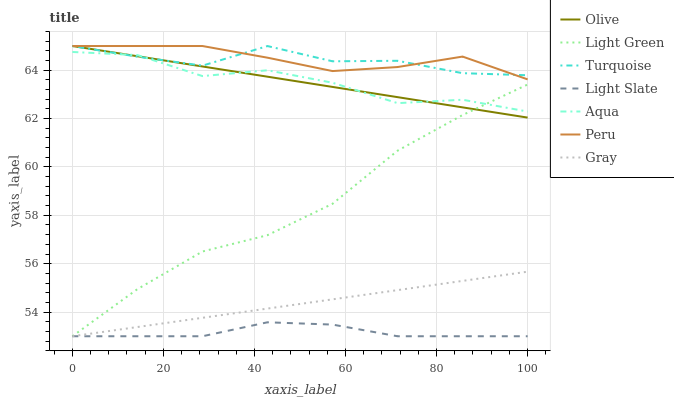Does Light Slate have the minimum area under the curve?
Answer yes or no. Yes. Does Peru have the maximum area under the curve?
Answer yes or no. Yes. Does Turquoise have the minimum area under the curve?
Answer yes or no. No. Does Turquoise have the maximum area under the curve?
Answer yes or no. No. Is Gray the smoothest?
Answer yes or no. Yes. Is Aqua the roughest?
Answer yes or no. Yes. Is Turquoise the smoothest?
Answer yes or no. No. Is Turquoise the roughest?
Answer yes or no. No. Does Gray have the lowest value?
Answer yes or no. Yes. Does Turquoise have the lowest value?
Answer yes or no. No. Does Olive have the highest value?
Answer yes or no. Yes. Does Light Green have the highest value?
Answer yes or no. No. Is Light Green less than Peru?
Answer yes or no. Yes. Is Peru greater than Gray?
Answer yes or no. Yes. Does Light Slate intersect Light Green?
Answer yes or no. Yes. Is Light Slate less than Light Green?
Answer yes or no. No. Is Light Slate greater than Light Green?
Answer yes or no. No. Does Light Green intersect Peru?
Answer yes or no. No. 